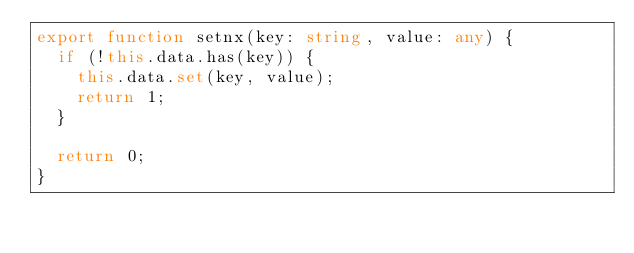<code> <loc_0><loc_0><loc_500><loc_500><_TypeScript_>export function setnx(key: string, value: any) {
  if (!this.data.has(key)) {
    this.data.set(key, value);
    return 1;
  }

  return 0;
}
</code> 